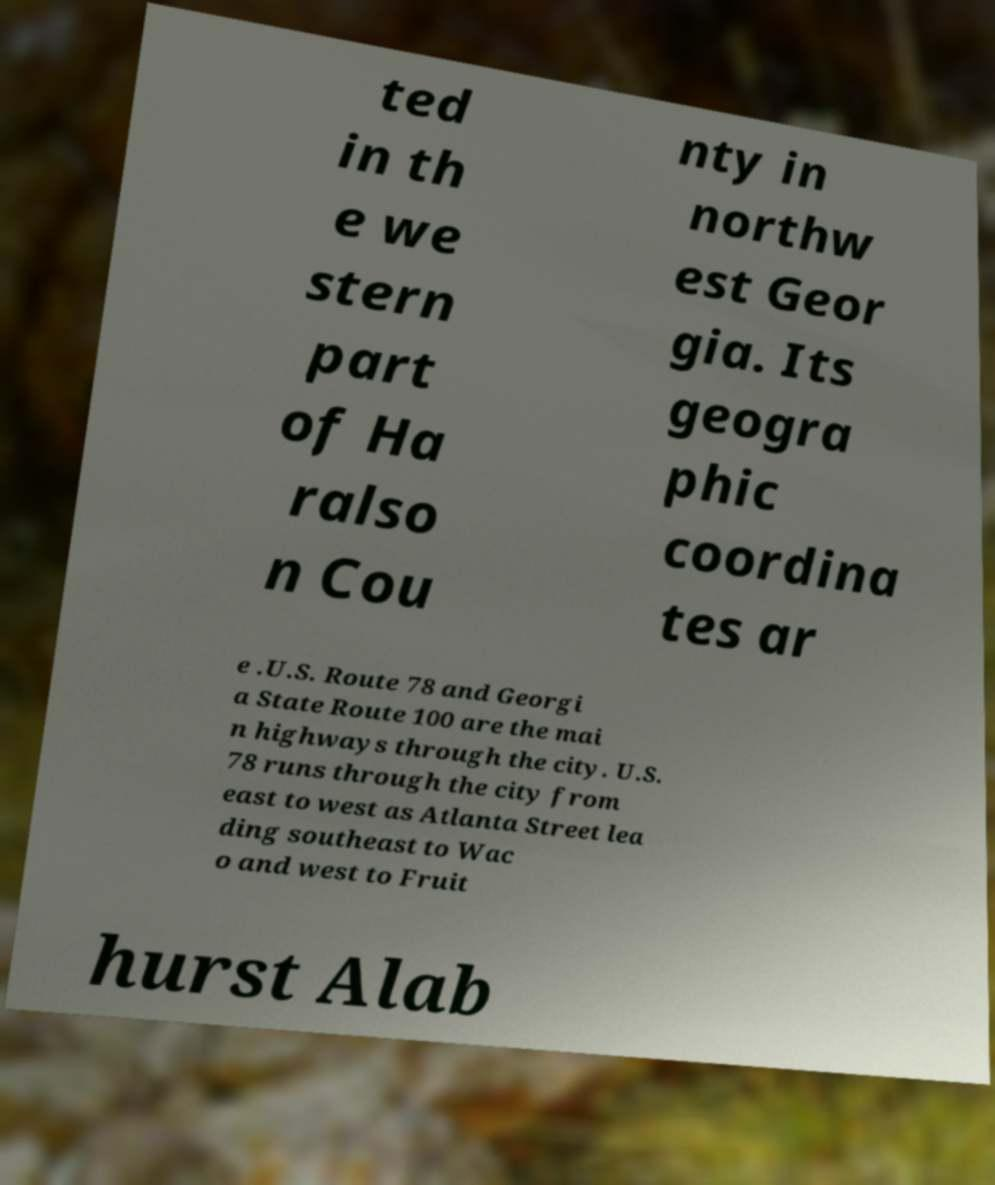Can you read and provide the text displayed in the image?This photo seems to have some interesting text. Can you extract and type it out for me? ted in th e we stern part of Ha ralso n Cou nty in northw est Geor gia. Its geogra phic coordina tes ar e .U.S. Route 78 and Georgi a State Route 100 are the mai n highways through the city. U.S. 78 runs through the city from east to west as Atlanta Street lea ding southeast to Wac o and west to Fruit hurst Alab 